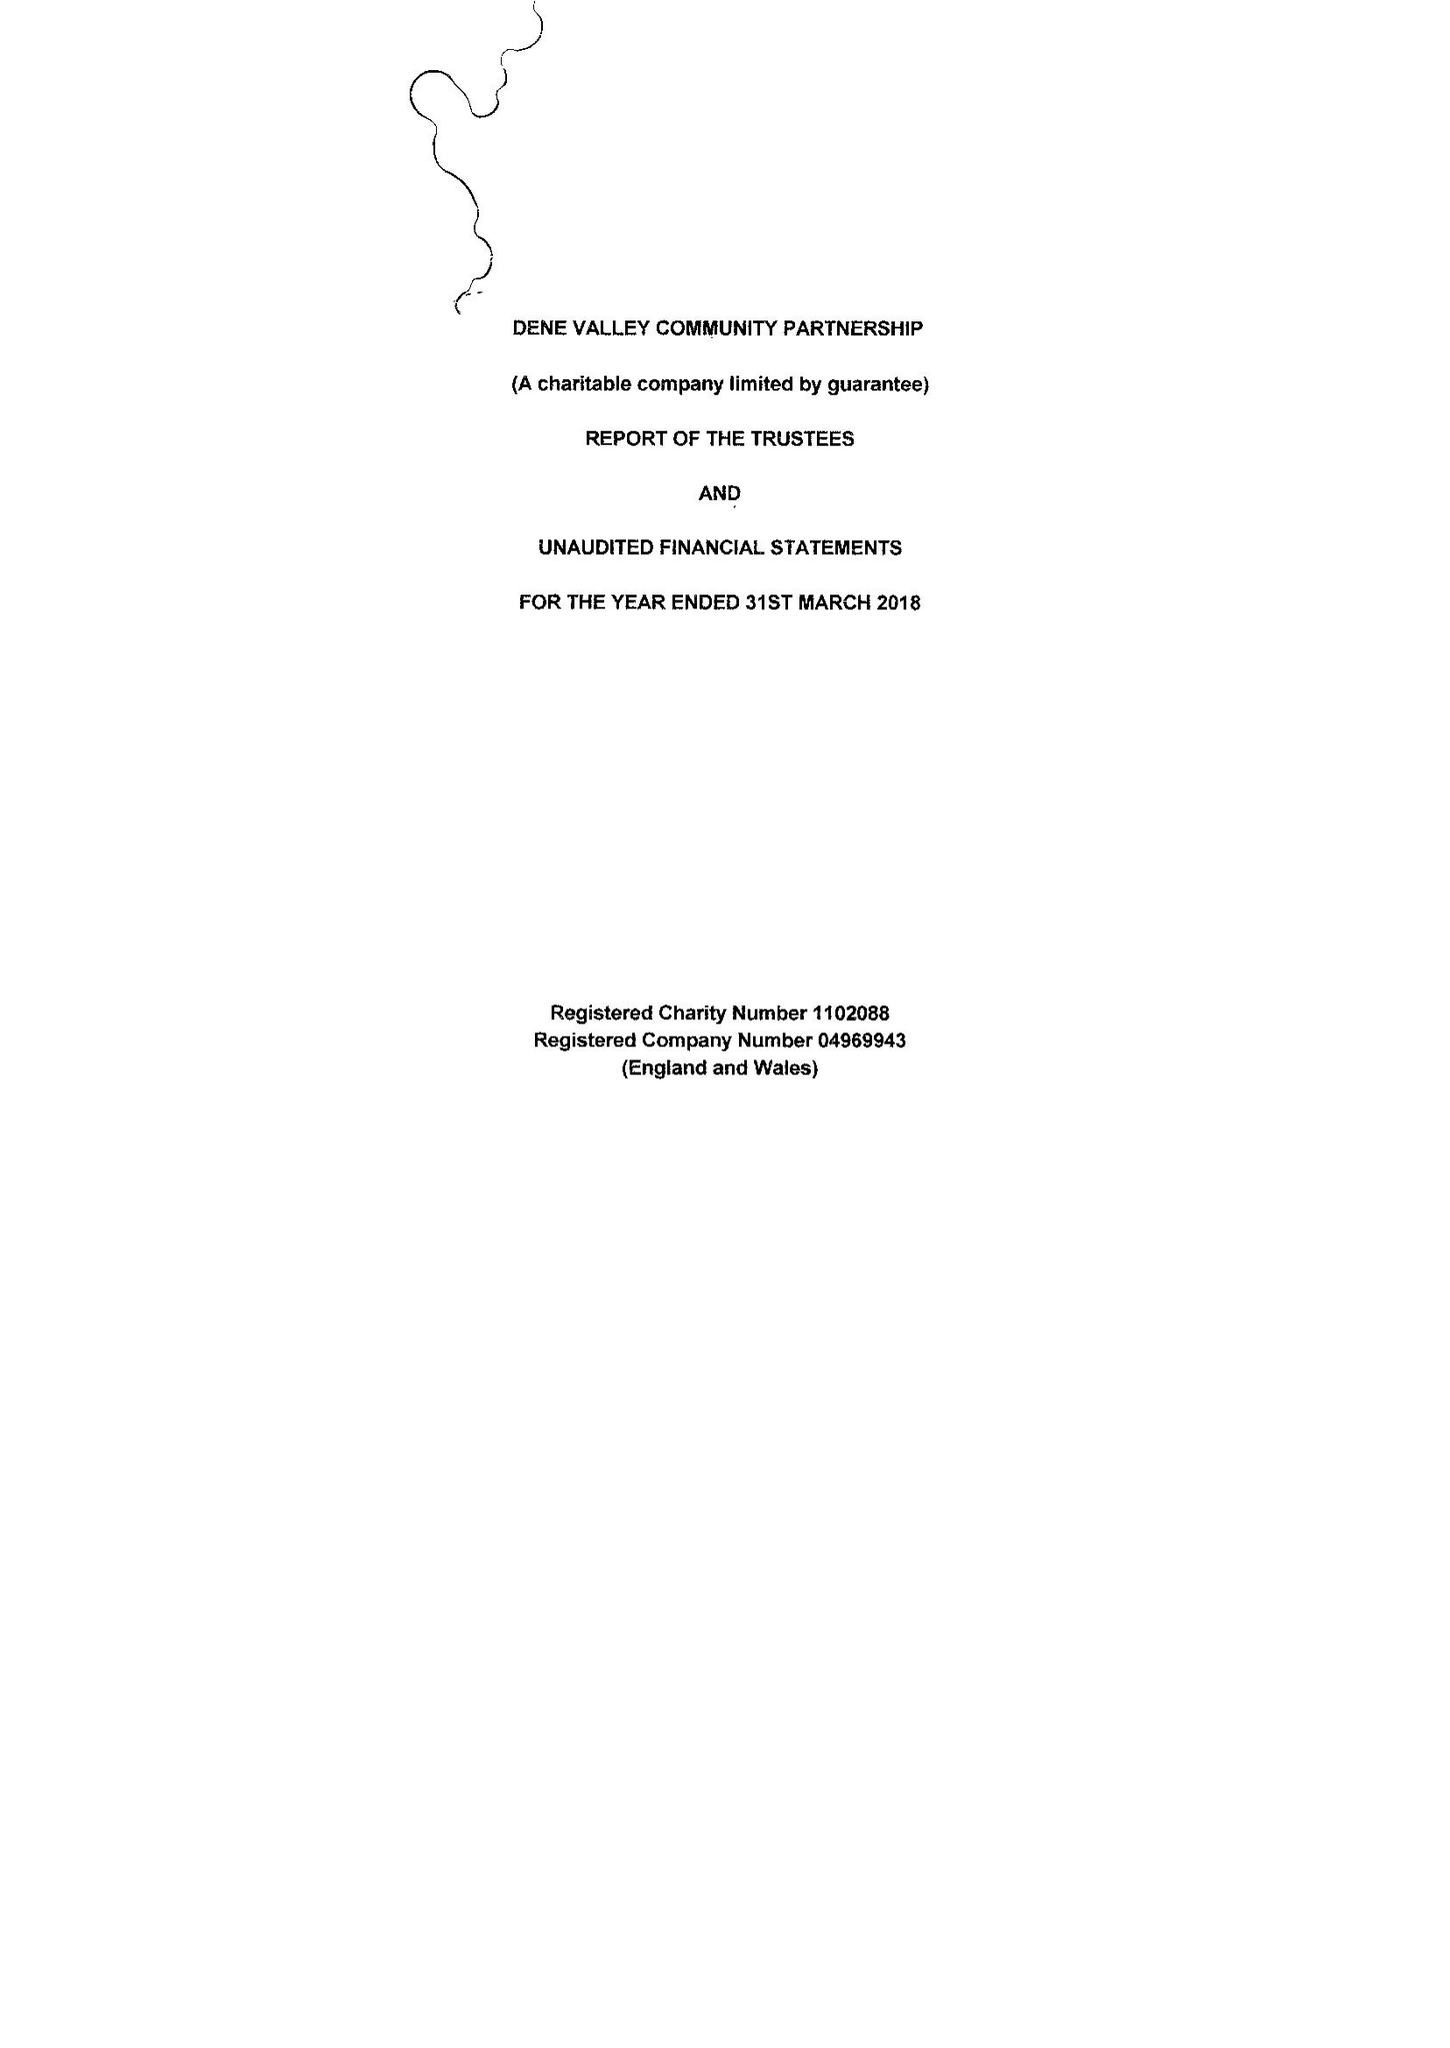What is the value for the income_annually_in_british_pounds?
Answer the question using a single word or phrase. 31247.00 